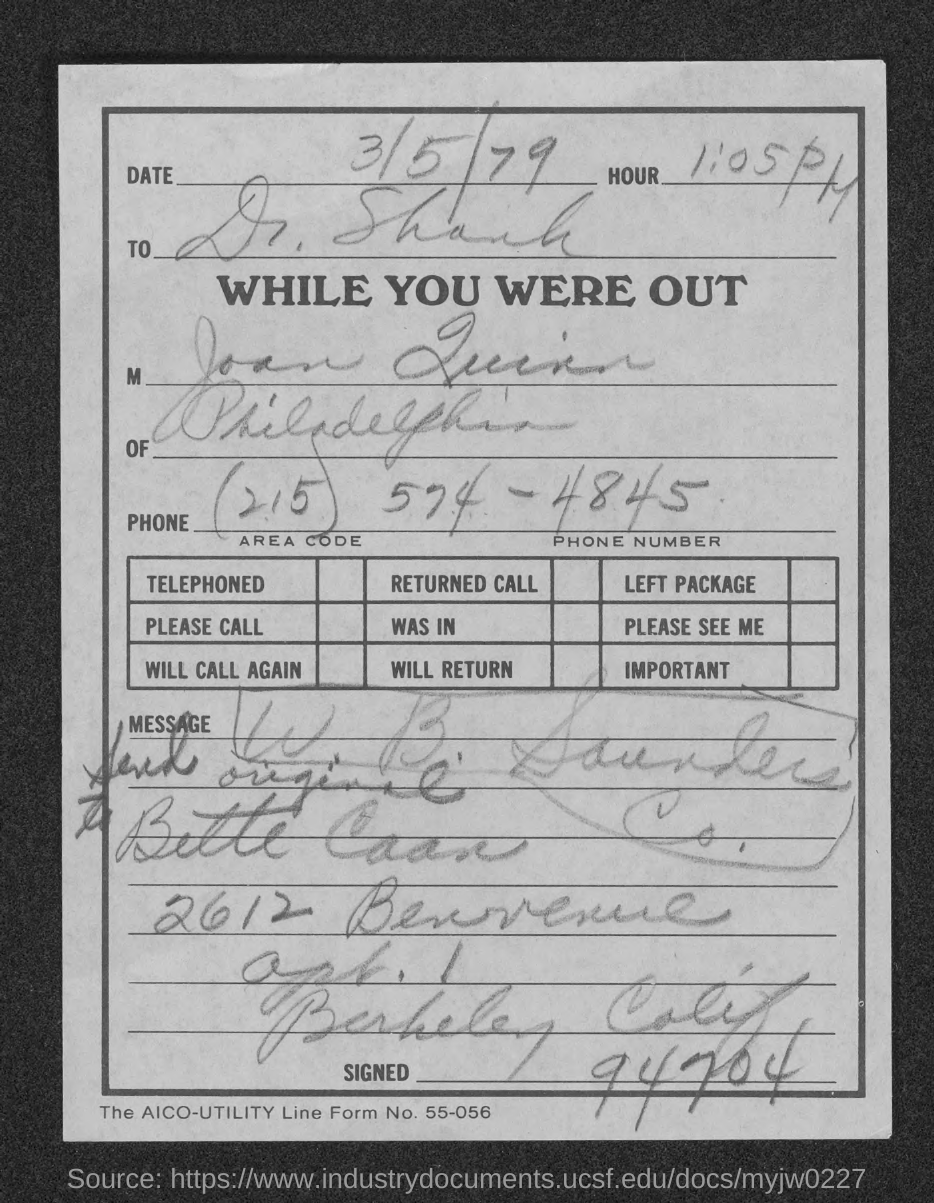What is the date mentioned in this document?
Offer a terse response. 3/5/79. What is the time/Hour given in the document?
Your response must be concise. 1:05 PM. To whom, the document is addressed?
Your answer should be very brief. Dr. Shank. 